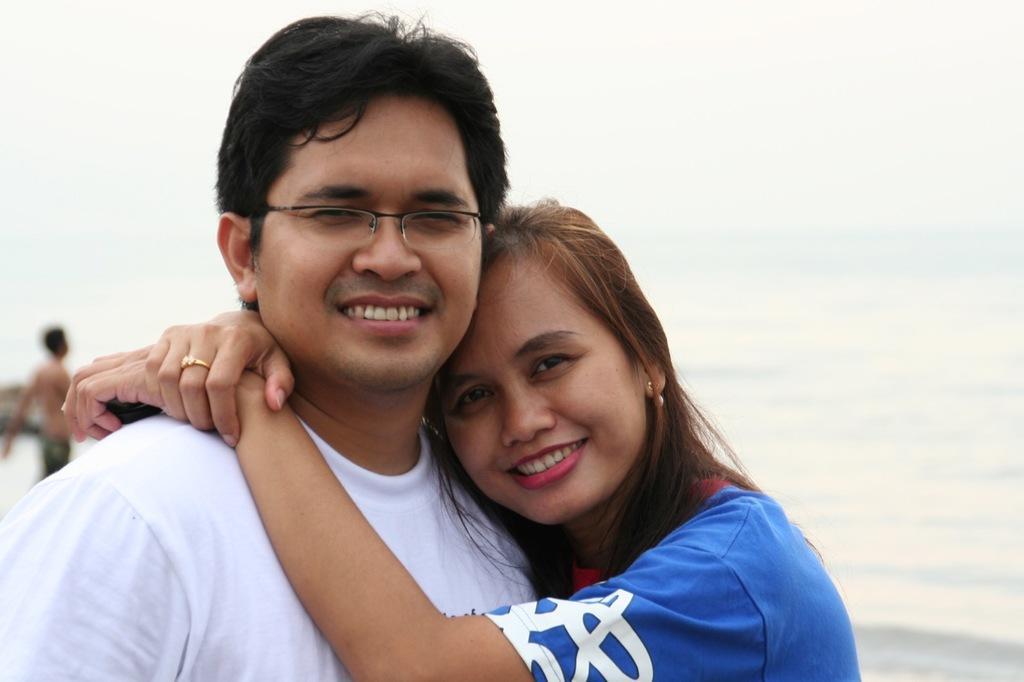In one or two sentences, can you explain what this image depicts? In this image I can see a man and a woman standing. Man is wearing white shirt and woman is wearing blue and white top. Back Side I can see water. The sky is in white color. 